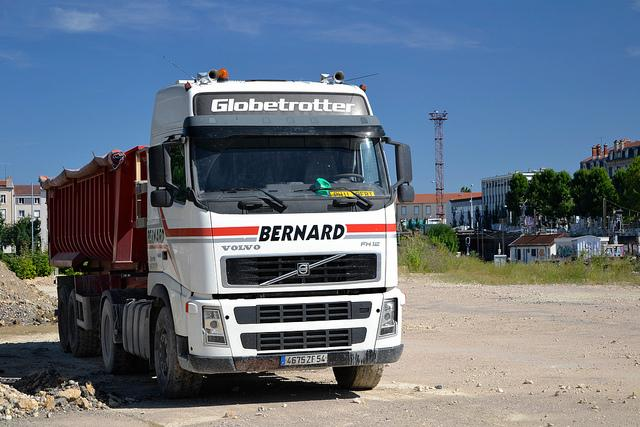This truck shares a name with a popular American Sporting expo group who plays what sport? basketball 